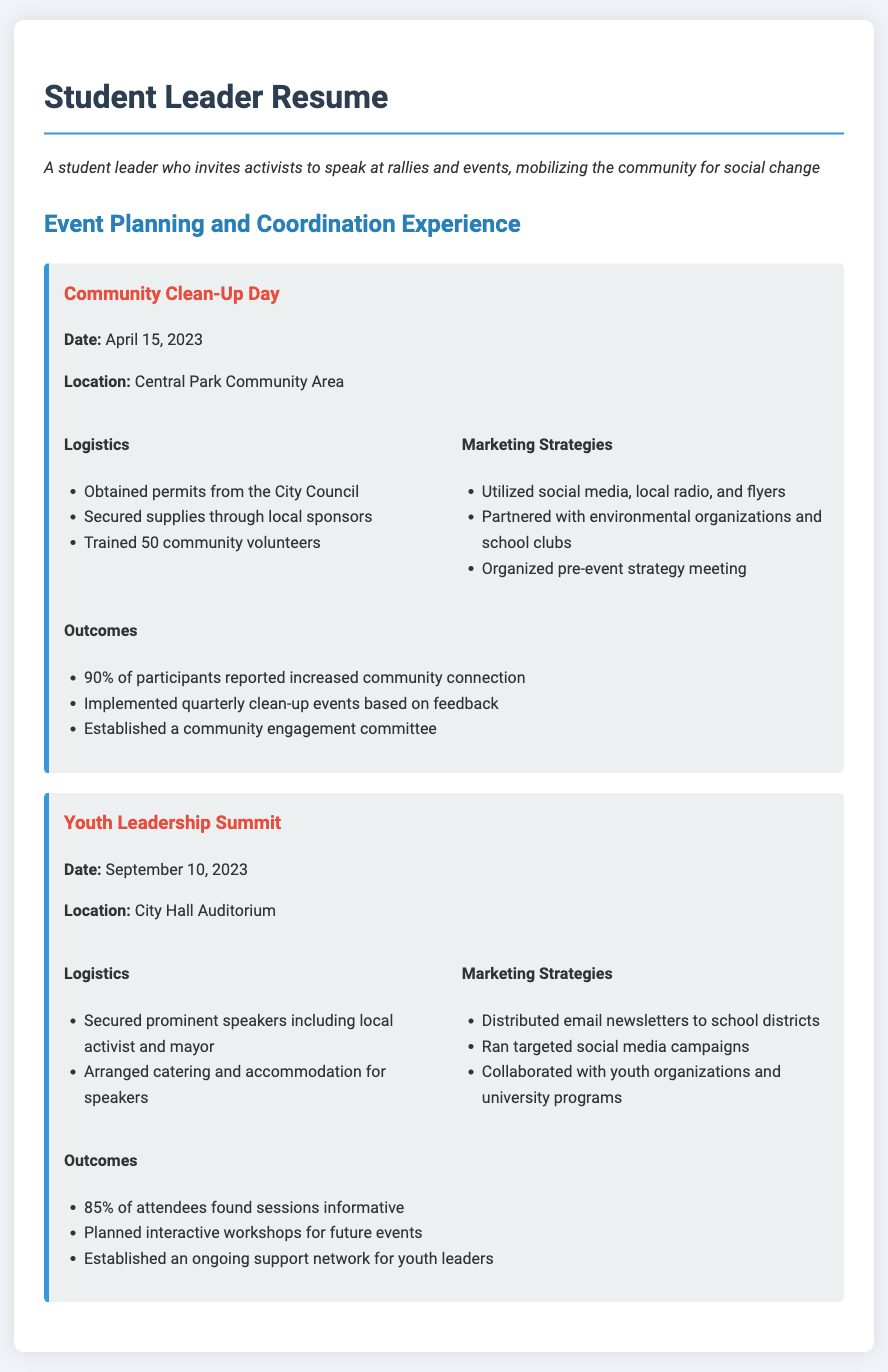what was the date of the Community Clean-Up Day? The date is explicitly mentioned in the event details section of the document.
Answer: April 15, 2023 where was the Youth Leadership Summit held? The location is specified in the header of the event for clarity.
Answer: City Hall Auditorium how many volunteers were trained for the Community Clean-Up Day? The number of trained volunteers is listed in the logistics section of the corresponding event.
Answer: 50 what percentage of participants reported increased community connection after the clean-up event? This statistic is found in the outcomes section of the Community Clean-Up Day.
Answer: 90% what marketing strategy was used for the Youth Leadership Summit? The document lists several strategies; the question seeks a specific example.
Answer: Distributed email newsletters which prominent speakers were secured for the Youth Leadership Summit? This information can be found in the logistics section of the event.
Answer: Local activist and mayor what was a planned outcome of the Youth Leadership Summit? The outcomes section specifies future plans that emerged from the event.
Answer: Interactive workshops for future events how did participants respond to the Youth Leadership Summit sessions? This feedback is directly available in the outcomes section of the summit.
Answer: 85% of attendees found sessions informative 